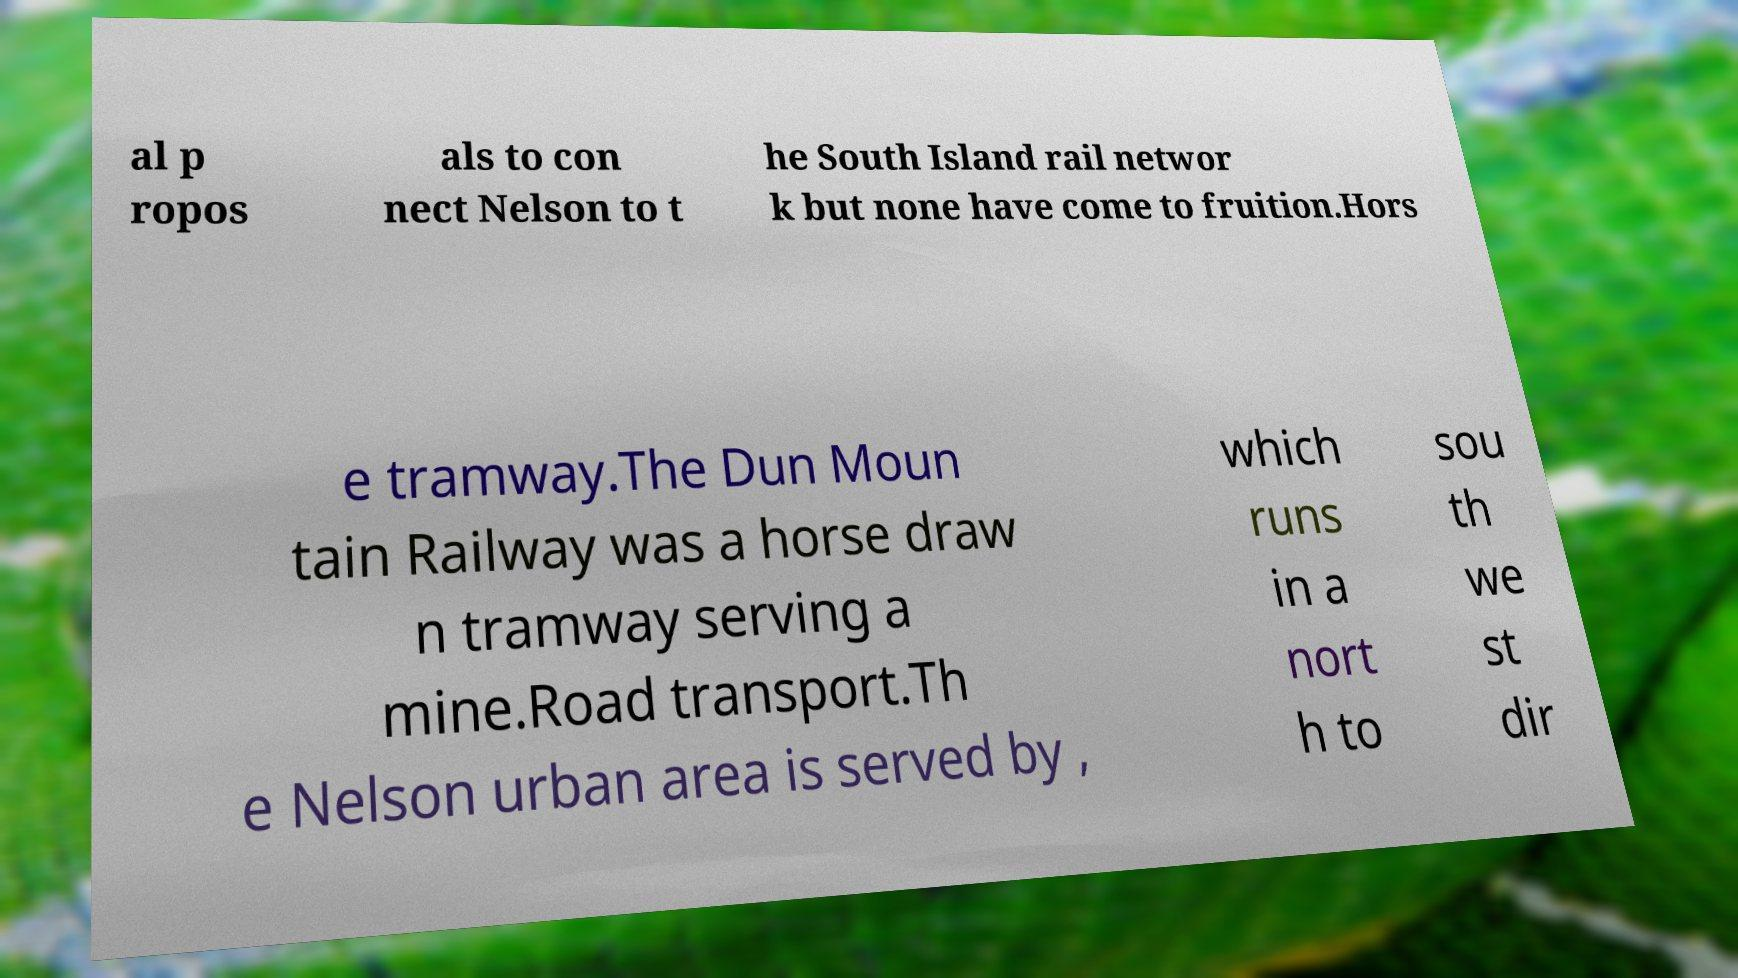I need the written content from this picture converted into text. Can you do that? al p ropos als to con nect Nelson to t he South Island rail networ k but none have come to fruition.Hors e tramway.The Dun Moun tain Railway was a horse draw n tramway serving a mine.Road transport.Th e Nelson urban area is served by , which runs in a nort h to sou th we st dir 